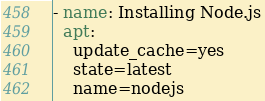Convert code to text. <code><loc_0><loc_0><loc_500><loc_500><_YAML_>- name: Installing Node.js
  apt:
    update_cache=yes
    state=latest
    name=nodejs</code> 